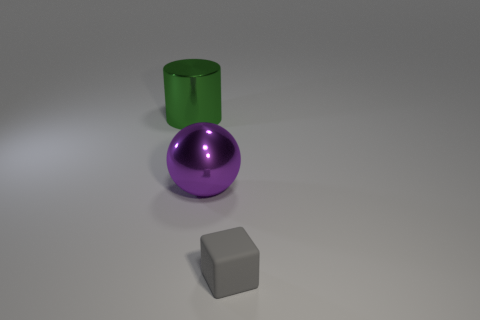Is there any other thing that is made of the same material as the small cube?
Offer a terse response. No. What size is the green metal thing?
Make the answer very short. Large. Are there fewer large objects that are left of the big shiny cylinder than large green metal cylinders?
Keep it short and to the point. Yes. What number of other shiny spheres have the same size as the sphere?
Make the answer very short. 0. Do the large thing right of the cylinder and the big shiny object that is behind the purple metallic object have the same color?
Offer a terse response. No. How many things are in front of the purple sphere?
Your answer should be very brief. 1. Are there any other small objects of the same shape as the gray rubber object?
Ensure brevity in your answer.  No. What is the color of the thing that is the same size as the metal cylinder?
Your response must be concise. Purple. Is the number of big spheres that are left of the large green metallic cylinder less than the number of large metal objects that are behind the metal sphere?
Ensure brevity in your answer.  Yes. There is a metallic thing behind the purple metal object; is its size the same as the big purple metallic thing?
Make the answer very short. Yes. 